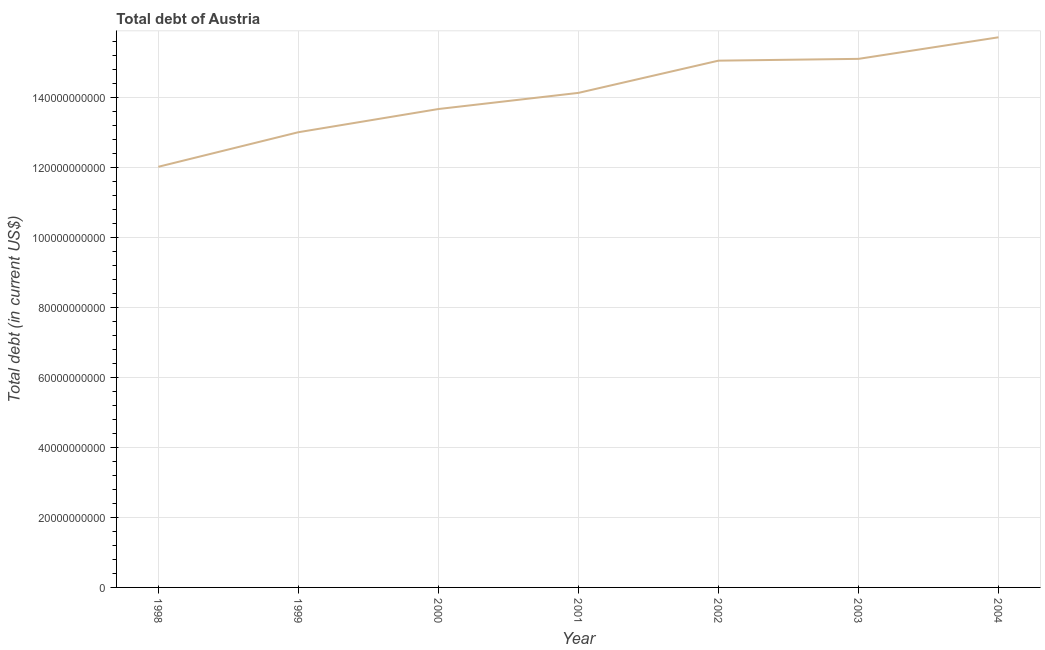What is the total debt in 2002?
Offer a terse response. 1.51e+11. Across all years, what is the maximum total debt?
Give a very brief answer. 1.57e+11. Across all years, what is the minimum total debt?
Provide a succinct answer. 1.20e+11. In which year was the total debt maximum?
Your answer should be very brief. 2004. In which year was the total debt minimum?
Offer a very short reply. 1998. What is the sum of the total debt?
Offer a terse response. 9.87e+11. What is the difference between the total debt in 1998 and 1999?
Your answer should be compact. -9.88e+09. What is the average total debt per year?
Keep it short and to the point. 1.41e+11. What is the median total debt?
Offer a very short reply. 1.41e+11. Do a majority of the years between 1998 and 2003 (inclusive) have total debt greater than 8000000000 US$?
Ensure brevity in your answer.  Yes. What is the ratio of the total debt in 2001 to that in 2002?
Your response must be concise. 0.94. Is the total debt in 1998 less than that in 2002?
Provide a short and direct response. Yes. What is the difference between the highest and the second highest total debt?
Offer a terse response. 6.16e+09. What is the difference between the highest and the lowest total debt?
Provide a succinct answer. 3.70e+1. Does the total debt monotonically increase over the years?
Offer a terse response. Yes. How many years are there in the graph?
Make the answer very short. 7. What is the difference between two consecutive major ticks on the Y-axis?
Provide a succinct answer. 2.00e+1. What is the title of the graph?
Give a very brief answer. Total debt of Austria. What is the label or title of the X-axis?
Offer a terse response. Year. What is the label or title of the Y-axis?
Give a very brief answer. Total debt (in current US$). What is the Total debt (in current US$) in 1998?
Your answer should be very brief. 1.20e+11. What is the Total debt (in current US$) in 1999?
Your response must be concise. 1.30e+11. What is the Total debt (in current US$) of 2000?
Provide a short and direct response. 1.37e+11. What is the Total debt (in current US$) of 2001?
Provide a short and direct response. 1.41e+11. What is the Total debt (in current US$) in 2002?
Your response must be concise. 1.51e+11. What is the Total debt (in current US$) of 2003?
Make the answer very short. 1.51e+11. What is the Total debt (in current US$) of 2004?
Offer a very short reply. 1.57e+11. What is the difference between the Total debt (in current US$) in 1998 and 1999?
Ensure brevity in your answer.  -9.88e+09. What is the difference between the Total debt (in current US$) in 1998 and 2000?
Ensure brevity in your answer.  -1.65e+1. What is the difference between the Total debt (in current US$) in 1998 and 2001?
Give a very brief answer. -2.11e+1. What is the difference between the Total debt (in current US$) in 1998 and 2002?
Offer a very short reply. -3.03e+1. What is the difference between the Total debt (in current US$) in 1998 and 2003?
Offer a very short reply. -3.08e+1. What is the difference between the Total debt (in current US$) in 1998 and 2004?
Your answer should be compact. -3.70e+1. What is the difference between the Total debt (in current US$) in 1999 and 2000?
Your response must be concise. -6.63e+09. What is the difference between the Total debt (in current US$) in 1999 and 2001?
Make the answer very short. -1.12e+1. What is the difference between the Total debt (in current US$) in 1999 and 2002?
Keep it short and to the point. -2.05e+1. What is the difference between the Total debt (in current US$) in 1999 and 2003?
Make the answer very short. -2.10e+1. What is the difference between the Total debt (in current US$) in 1999 and 2004?
Offer a terse response. -2.71e+1. What is the difference between the Total debt (in current US$) in 2000 and 2001?
Ensure brevity in your answer.  -4.61e+09. What is the difference between the Total debt (in current US$) in 2000 and 2002?
Provide a short and direct response. -1.38e+1. What is the difference between the Total debt (in current US$) in 2000 and 2003?
Your answer should be compact. -1.43e+1. What is the difference between the Total debt (in current US$) in 2000 and 2004?
Give a very brief answer. -2.05e+1. What is the difference between the Total debt (in current US$) in 2001 and 2002?
Provide a short and direct response. -9.21e+09. What is the difference between the Total debt (in current US$) in 2001 and 2003?
Provide a succinct answer. -9.72e+09. What is the difference between the Total debt (in current US$) in 2001 and 2004?
Your answer should be very brief. -1.59e+1. What is the difference between the Total debt (in current US$) in 2002 and 2003?
Ensure brevity in your answer.  -5.14e+08. What is the difference between the Total debt (in current US$) in 2002 and 2004?
Provide a short and direct response. -6.68e+09. What is the difference between the Total debt (in current US$) in 2003 and 2004?
Your answer should be very brief. -6.16e+09. What is the ratio of the Total debt (in current US$) in 1998 to that in 1999?
Your answer should be very brief. 0.92. What is the ratio of the Total debt (in current US$) in 1998 to that in 2000?
Give a very brief answer. 0.88. What is the ratio of the Total debt (in current US$) in 1998 to that in 2001?
Make the answer very short. 0.85. What is the ratio of the Total debt (in current US$) in 1998 to that in 2002?
Your response must be concise. 0.8. What is the ratio of the Total debt (in current US$) in 1998 to that in 2003?
Make the answer very short. 0.8. What is the ratio of the Total debt (in current US$) in 1998 to that in 2004?
Offer a terse response. 0.77. What is the ratio of the Total debt (in current US$) in 1999 to that in 2002?
Provide a succinct answer. 0.86. What is the ratio of the Total debt (in current US$) in 1999 to that in 2003?
Your response must be concise. 0.86. What is the ratio of the Total debt (in current US$) in 1999 to that in 2004?
Provide a short and direct response. 0.83. What is the ratio of the Total debt (in current US$) in 2000 to that in 2001?
Make the answer very short. 0.97. What is the ratio of the Total debt (in current US$) in 2000 to that in 2002?
Your answer should be compact. 0.91. What is the ratio of the Total debt (in current US$) in 2000 to that in 2003?
Make the answer very short. 0.91. What is the ratio of the Total debt (in current US$) in 2000 to that in 2004?
Provide a succinct answer. 0.87. What is the ratio of the Total debt (in current US$) in 2001 to that in 2002?
Give a very brief answer. 0.94. What is the ratio of the Total debt (in current US$) in 2001 to that in 2003?
Offer a terse response. 0.94. What is the ratio of the Total debt (in current US$) in 2001 to that in 2004?
Give a very brief answer. 0.9. What is the ratio of the Total debt (in current US$) in 2002 to that in 2004?
Give a very brief answer. 0.96. 